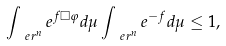Convert formula to latex. <formula><loc_0><loc_0><loc_500><loc_500>\int _ { \ e r ^ { n } } e ^ { f \Box \varphi } d \mu \int _ { \ e r ^ { n } } e ^ { - f } d \mu \leq 1 ,</formula> 